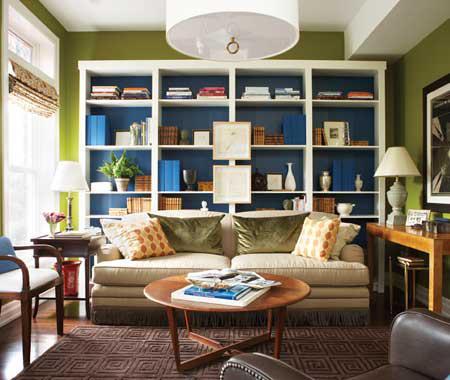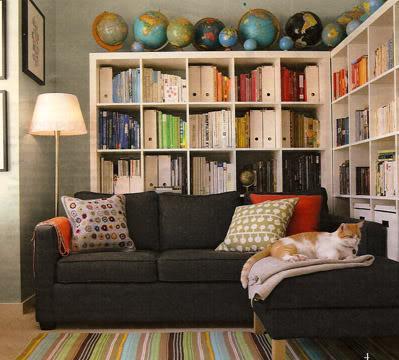The first image is the image on the left, the second image is the image on the right. For the images shown, is this caption "In one image a couch sits across the end of a room with white shelves on the wall behind and the wall to the side." true? Answer yes or no. Yes. The first image is the image on the left, the second image is the image on the right. Given the left and right images, does the statement "A room includes a round table in front of a neutral couch, which sits in front of a wall-filling white bookcase and something olive-green." hold true? Answer yes or no. Yes. 